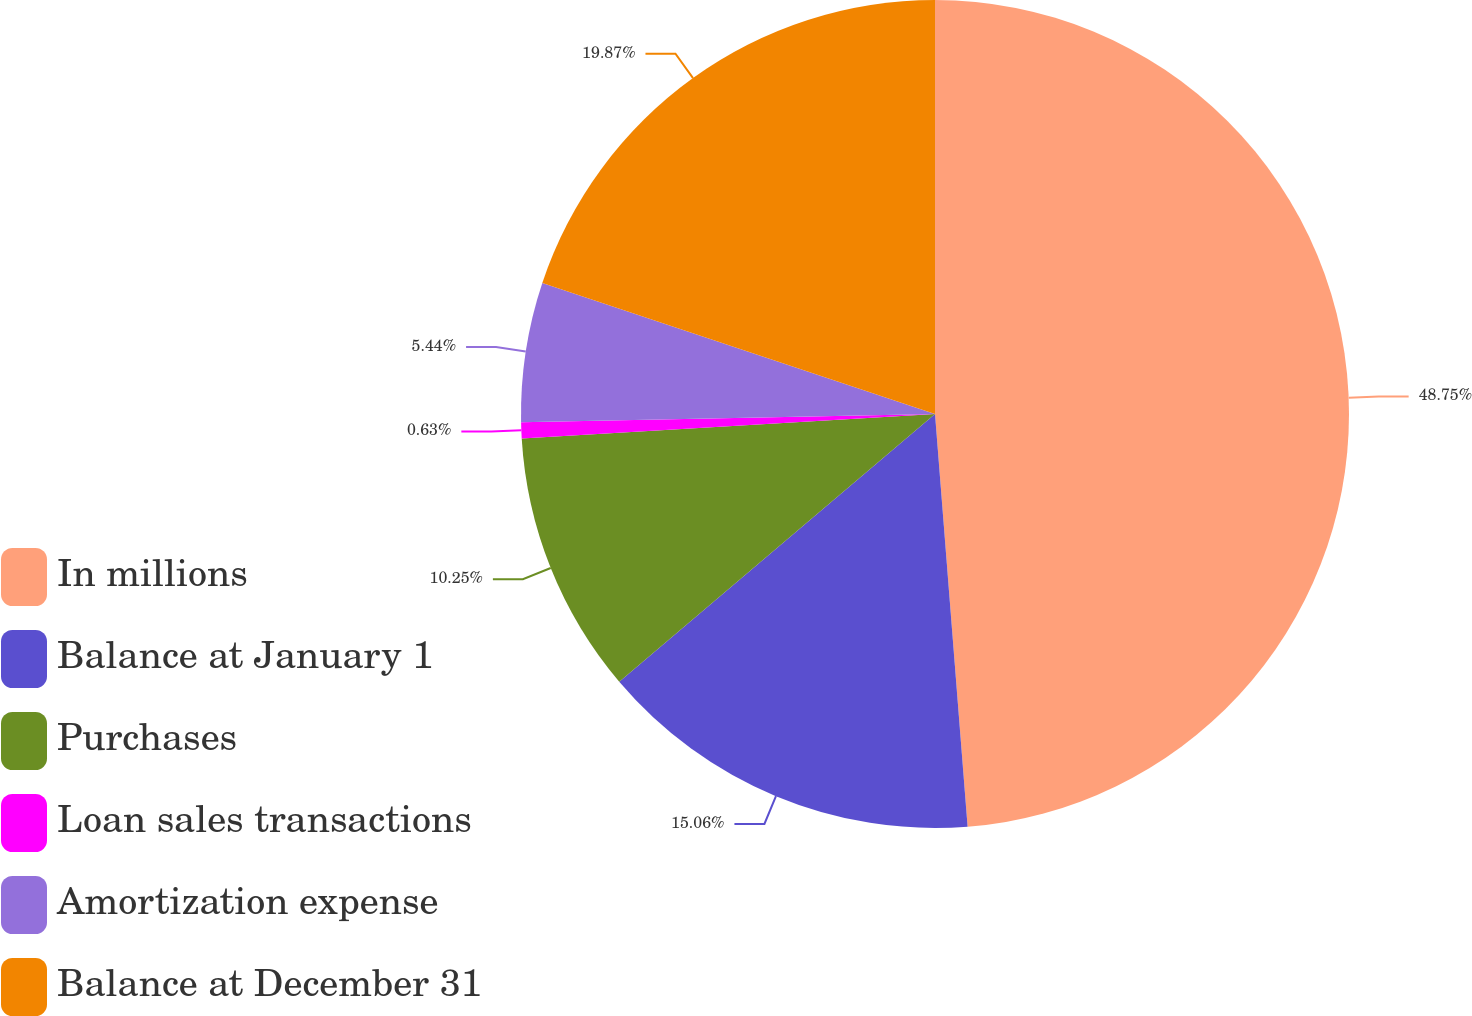<chart> <loc_0><loc_0><loc_500><loc_500><pie_chart><fcel>In millions<fcel>Balance at January 1<fcel>Purchases<fcel>Loan sales transactions<fcel>Amortization expense<fcel>Balance at December 31<nl><fcel>48.74%<fcel>15.06%<fcel>10.25%<fcel>0.63%<fcel>5.44%<fcel>19.87%<nl></chart> 